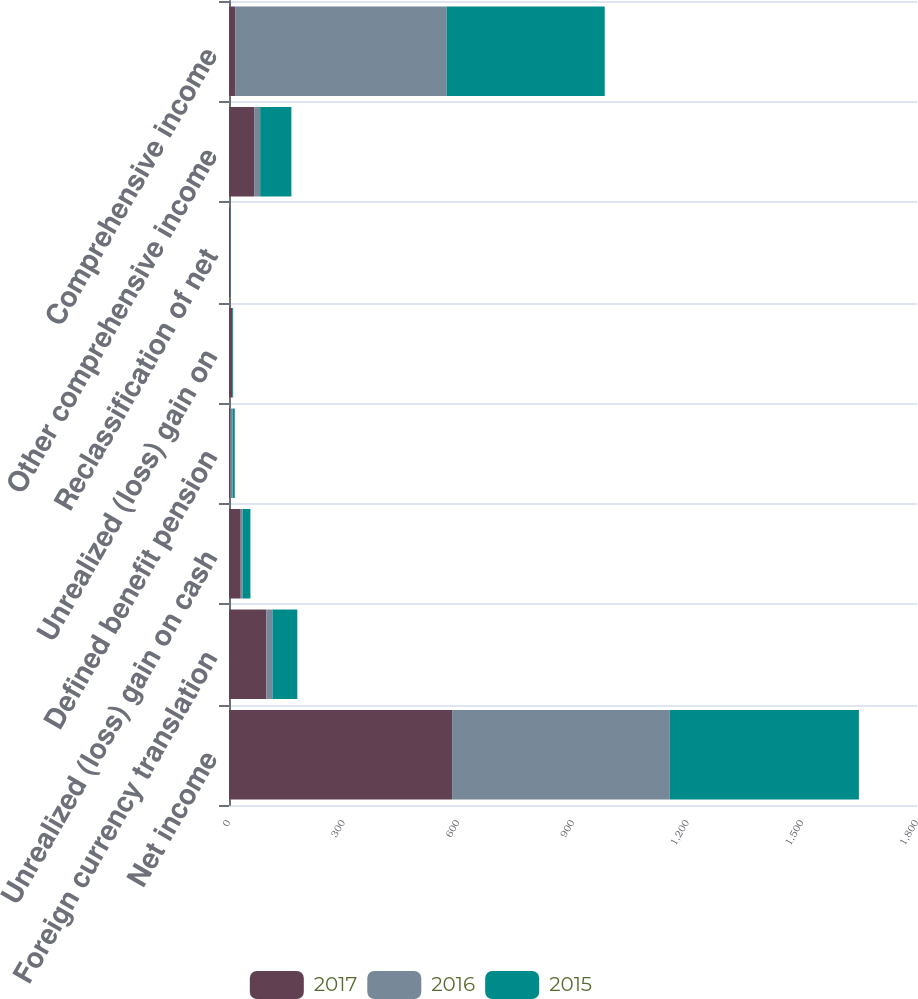Convert chart to OTSL. <chart><loc_0><loc_0><loc_500><loc_500><stacked_bar_chart><ecel><fcel>Net income<fcel>Foreign currency translation<fcel>Unrealized (loss) gain on cash<fcel>Defined benefit pension<fcel>Unrealized (loss) gain on<fcel>Reclassification of net<fcel>Other comprehensive income<fcel>Comprehensive income<nl><fcel>2017<fcel>583.6<fcel>97.5<fcel>30.6<fcel>3.5<fcel>7.8<fcel>3.1<fcel>65.7<fcel>16.1<nl><fcel>2016<fcel>569.5<fcel>16.1<fcel>4.9<fcel>6.2<fcel>0.5<fcel>1.1<fcel>15.8<fcel>553.7<nl><fcel>2015<fcel>494.9<fcel>65.1<fcel>20.5<fcel>5.4<fcel>2.6<fcel>1.1<fcel>81.7<fcel>413.2<nl></chart> 